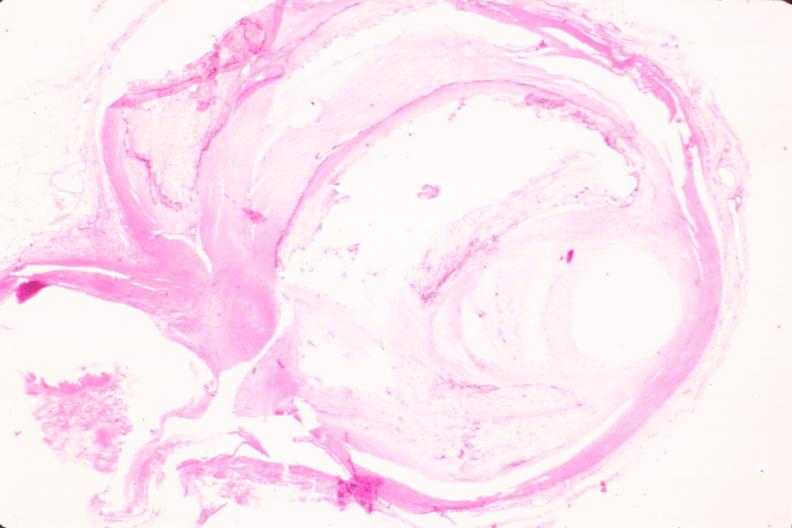what is present?
Answer the question using a single word or phrase. Cardiovascular 